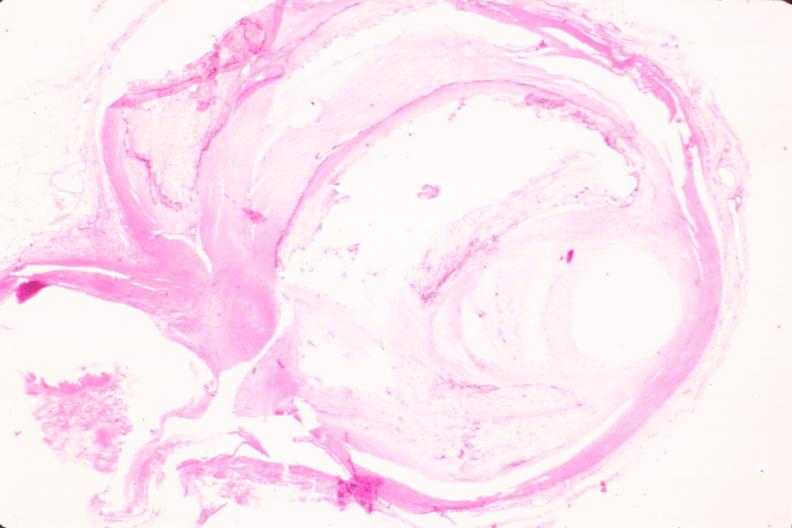what is present?
Answer the question using a single word or phrase. Cardiovascular 